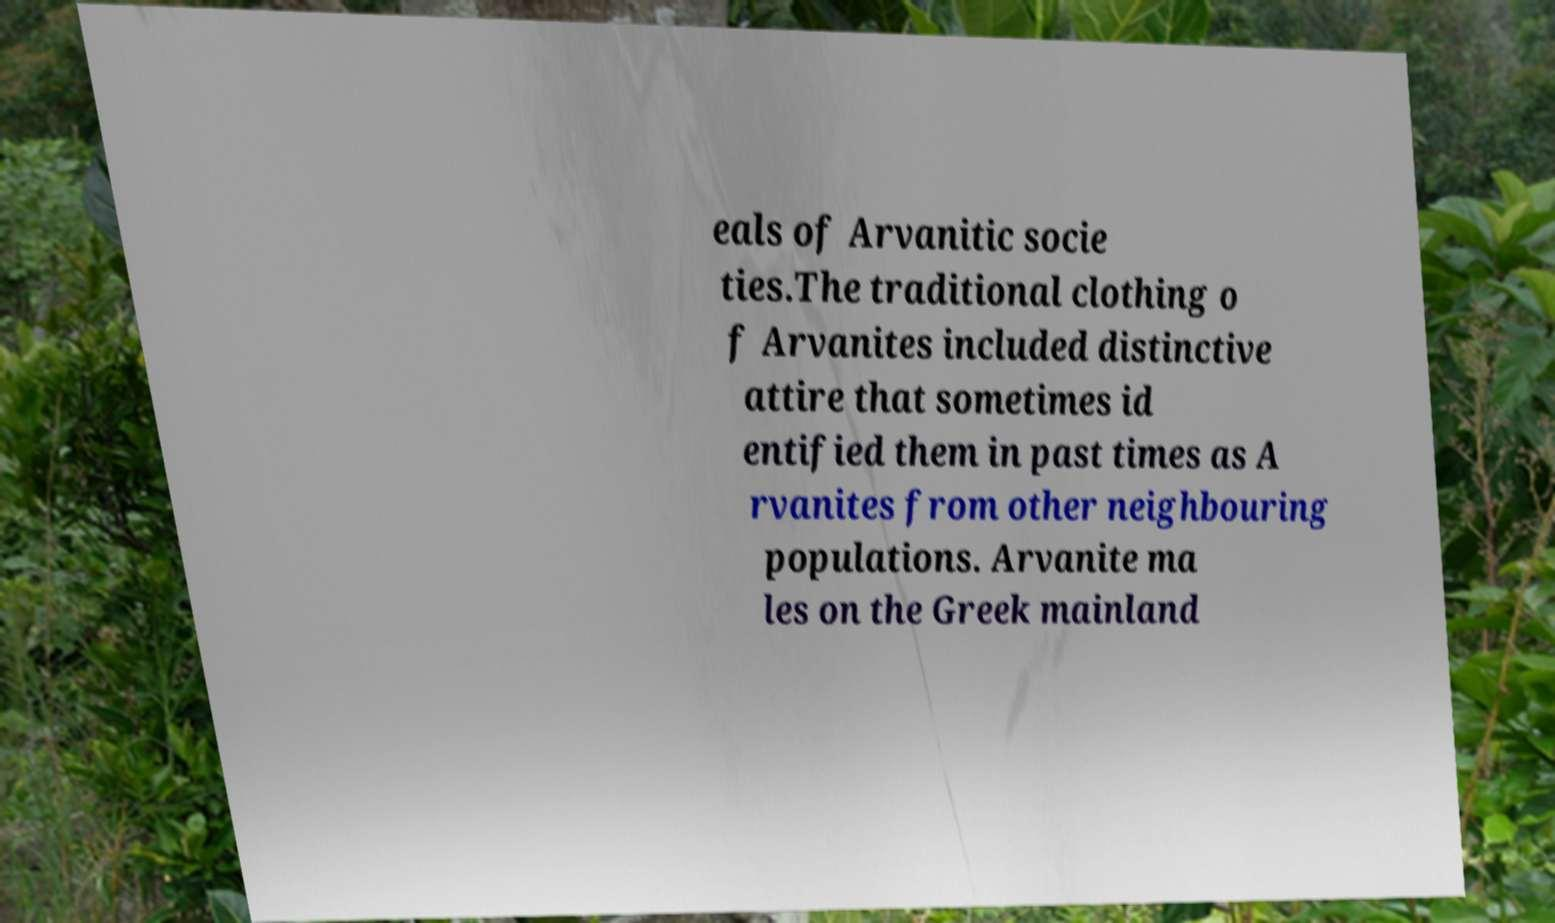Please identify and transcribe the text found in this image. eals of Arvanitic socie ties.The traditional clothing o f Arvanites included distinctive attire that sometimes id entified them in past times as A rvanites from other neighbouring populations. Arvanite ma les on the Greek mainland 